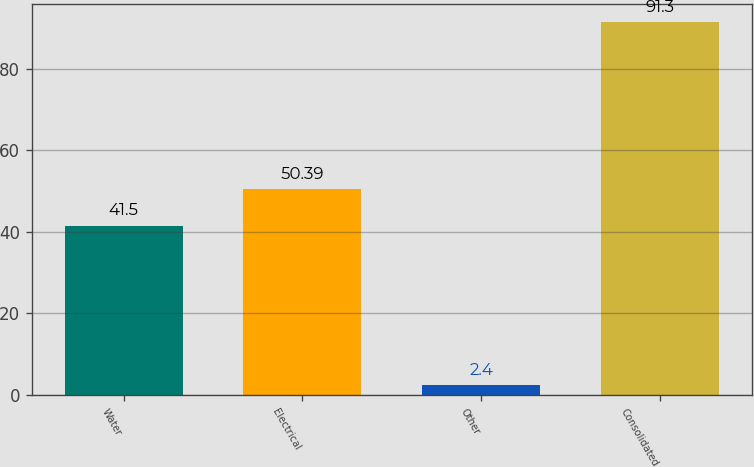<chart> <loc_0><loc_0><loc_500><loc_500><bar_chart><fcel>Water<fcel>Electrical<fcel>Other<fcel>Consolidated<nl><fcel>41.5<fcel>50.39<fcel>2.4<fcel>91.3<nl></chart> 